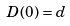Convert formula to latex. <formula><loc_0><loc_0><loc_500><loc_500>D ( 0 ) = d</formula> 